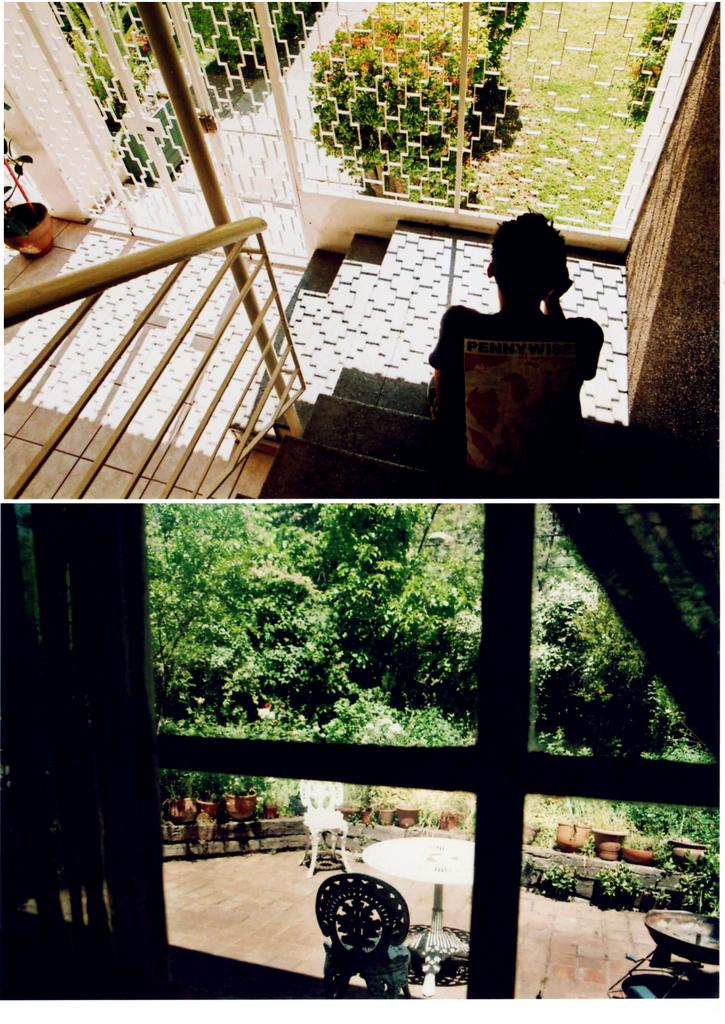What type of artwork is the image? The image is a collage. What type of furniture is visible in the image? There is a table and chairs in the image. What architectural feature is present in the image? There are windows in the image. What type of plant is in the image? There is a house plant in the image. What type of natural scenery is visible in the image? There are trees in the image. What is the person in the image doing? There is a person sitting on steps in the image. What type of guitar is the person playing in the image? There is no guitar present in the image; the person is sitting on steps. What is the profit margin of the house plant in the image? The image does not provide information about the profit margin of the house plant, as it is not a commercial context. 